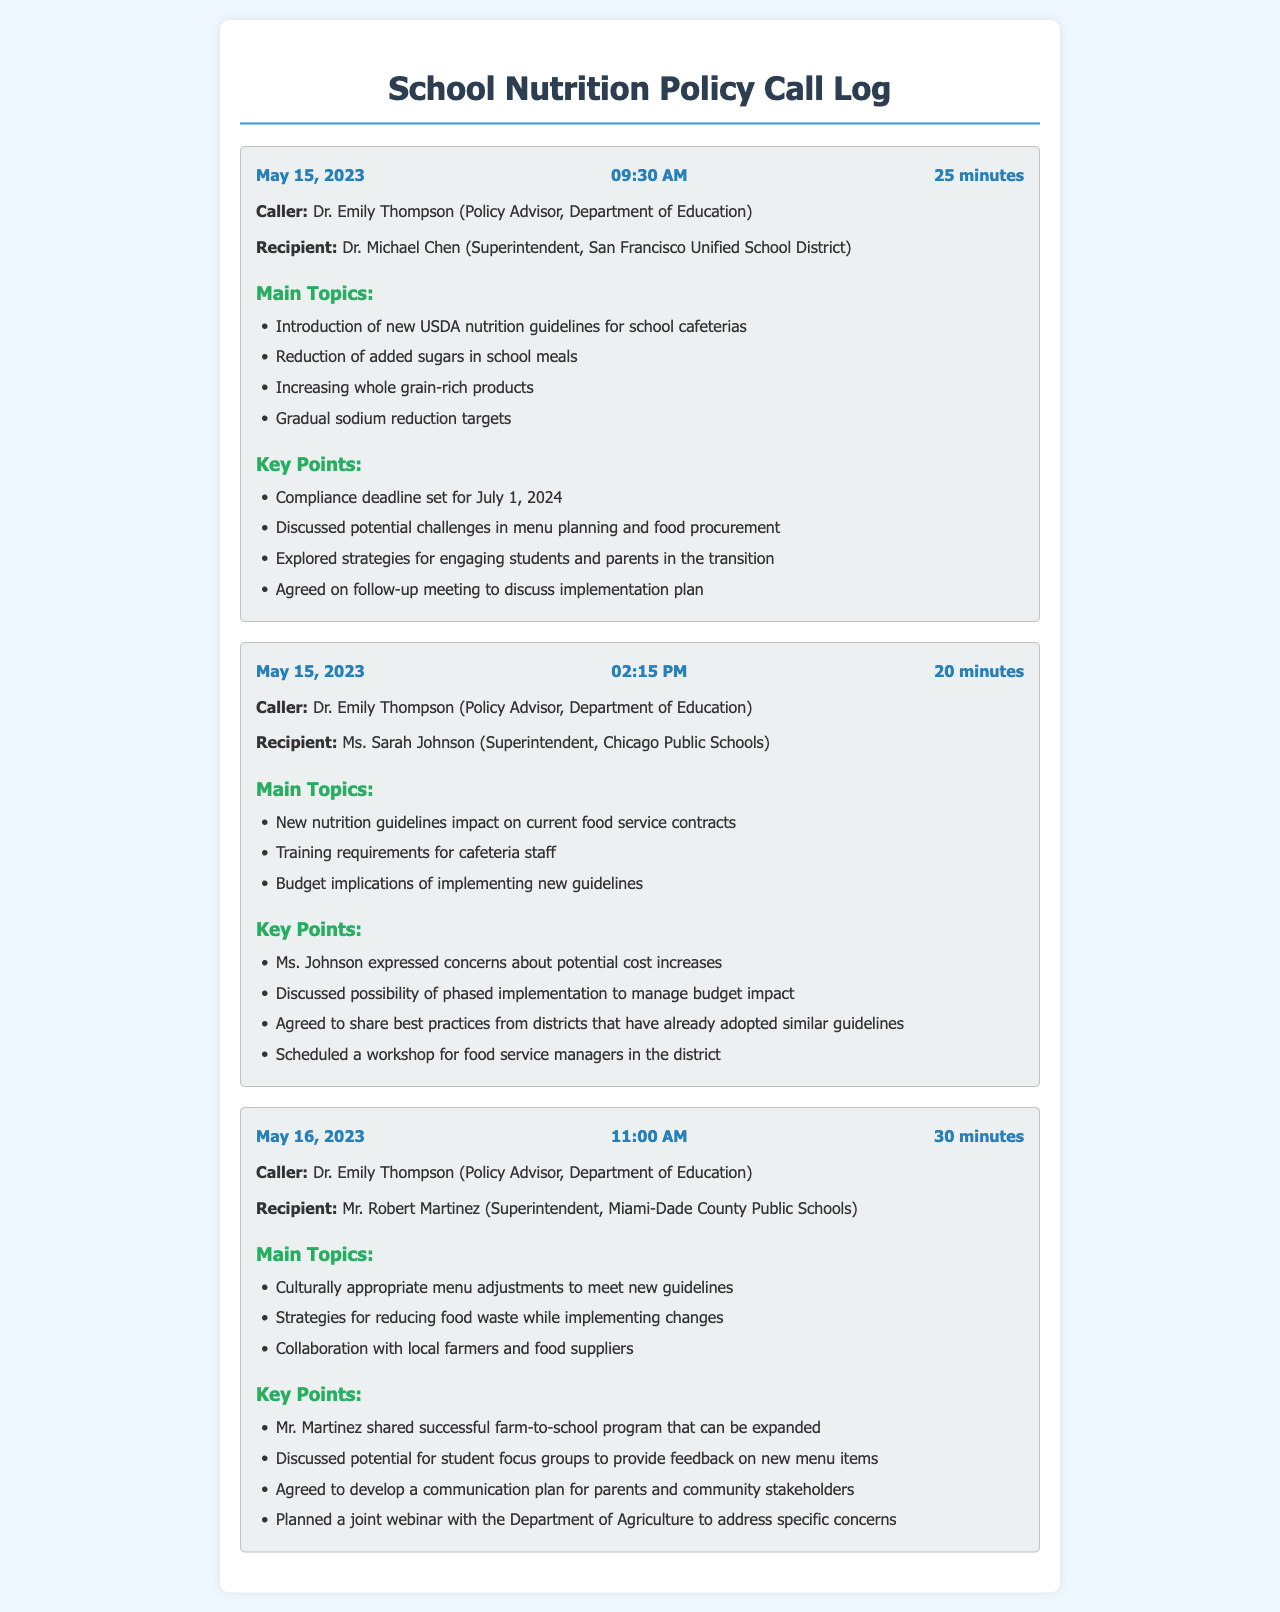What is the date of the call with Dr. Michael Chen? The call with Dr. Michael Chen took place on May 15, 2023, as mentioned in the call log.
Answer: May 15, 2023 Who is the caller for the call lasting 30 minutes on May 16, 2023? The caller for the 30-minute call on May 16, 2023, is Dr. Emily Thompson, as indicated in the call log.
Answer: Dr. Emily Thompson What is one of the main topics discussed with Ms. Sarah Johnson? The main topic discussed with Ms. Sarah Johnson is about new nutrition guidelines' impact on current food service contracts, which is explicitly listed in the call log.
Answer: New nutrition guidelines impact on current food service contracts What is the compliance deadline for the new USDA nutrition guidelines? The compliance deadline set for the new USDA nutrition guidelines is July 1, 2024, as stated in the key points of the call log.
Answer: July 1, 2024 What concern did Ms. Sarah Johnson express during her call? Ms. Sarah Johnson expressed concerns about potential cost increases related to the new nutrition guidelines, as noted in the key points section.
Answer: Potential cost increases What strategy did Mr. Robert Martinez share to reduce food waste? Mr. Robert Martinez discussed strategies for reducing food waste while implementing changes, as indicated in the main topics of the call log.
Answer: Reducing food waste while implementing changes What was agreed upon in the call with Dr. Michael Chen regarding future meetings? In the call with Dr. Michael Chen, it was agreed to have a follow-up meeting to discuss the implementation plan, as mentioned in the key points.
Answer: Follow-up meeting to discuss implementation plan What is the total duration of the calls recorded on May 15, 2023? The total duration of the calls on May 15, 2023, is 25 minutes + 20 minutes = 45 minutes, as calculated from the individual call durations.
Answer: 45 minutes 